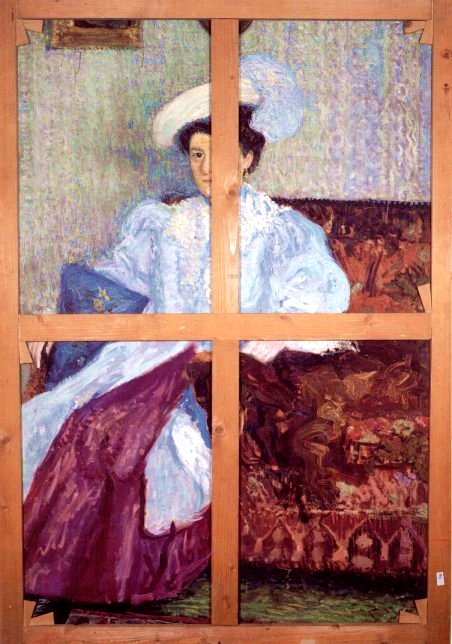What's an interesting interpretation of the white hat in this painting? An interesting interpretation of the white hat in this painting could be that it symbolizes purity and thoughtfulness. The white color contrasts with the more vibrant hues surrounding it, possibly indicating the woman's clear and focused mind despite the complexities of her environment. It could also represent a societal status, signifying elegance and grace. Alternatively, the hat might serve as a visual anchor, drawing the viewer's eye and connecting the different elements of the painting, emphasizing the woman's central role in the narrative. What if the wooden beams were not part of the painting? How would it change the perception? If the wooden beams were not part of the painting, the perception of the scene would change significantly. Without the divisions created by the beams, the image would appear as a single, unified composition, allowing for a more seamless and continuous observation of the scene. The narrative told by the different panels would merge into a cohesive whole, perhaps highlighting the interconnectedness of the elements within the painting. The absence of the beams might also shift the focus more directly to the woman, her attire, and her surroundings, creating a more straightforward and uninterrupted depiction of her serene moment. What if the red couch could talk? What stories might it tell? If the red couch in the painting could talk, it might tell stories of countless moments spent in quiet contemplation or lively conversation. It could recount the many afternoons it has seen, bathed in sunlight streaming from the windows, witnessing the lives of those who have sat upon it. The couch might share tales of whispered secrets and heartfelt confessions, of laughter and tears shared in its presence. It could reveal the history of the room, the changing fashions, and the evolving décor, providing a rich tapestry of the past seen from its unique vantage point. The stories would add depth and character to the painting, enriching the viewer's understanding of the scene. 